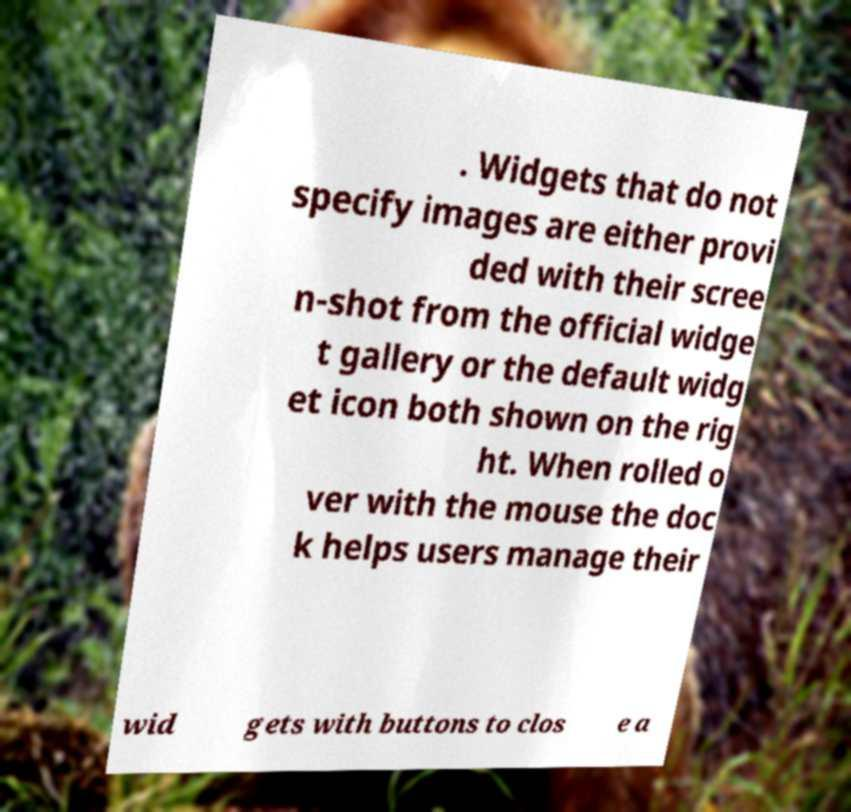What messages or text are displayed in this image? I need them in a readable, typed format. . Widgets that do not specify images are either provi ded with their scree n-shot from the official widge t gallery or the default widg et icon both shown on the rig ht. When rolled o ver with the mouse the doc k helps users manage their wid gets with buttons to clos e a 